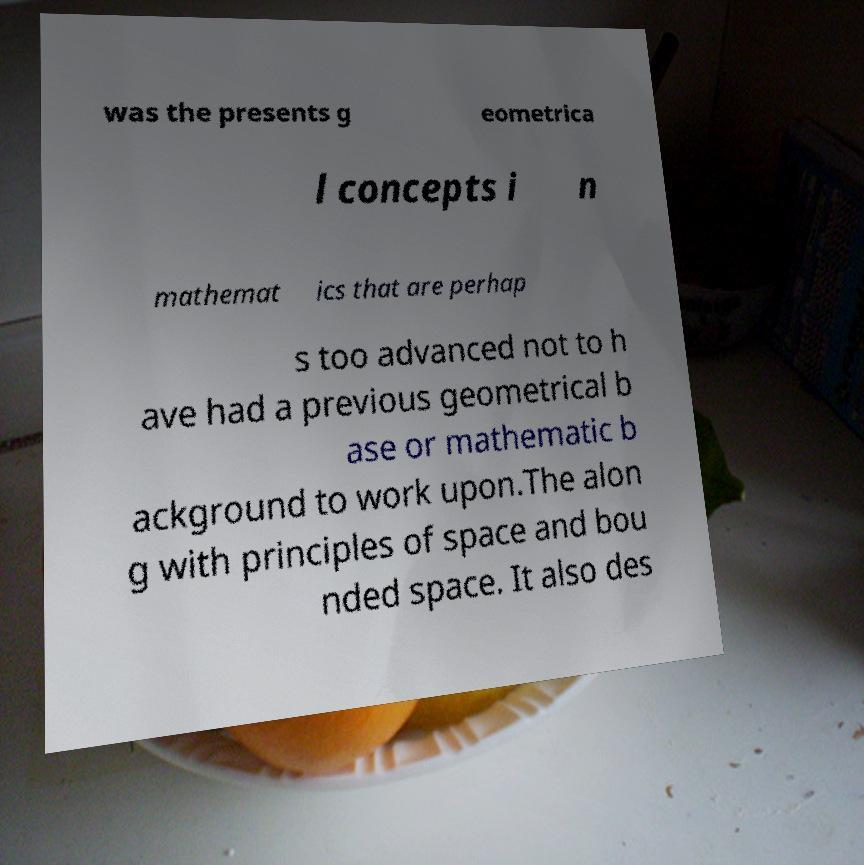Could you extract and type out the text from this image? was the presents g eometrica l concepts i n mathemat ics that are perhap s too advanced not to h ave had a previous geometrical b ase or mathematic b ackground to work upon.The alon g with principles of space and bou nded space. It also des 